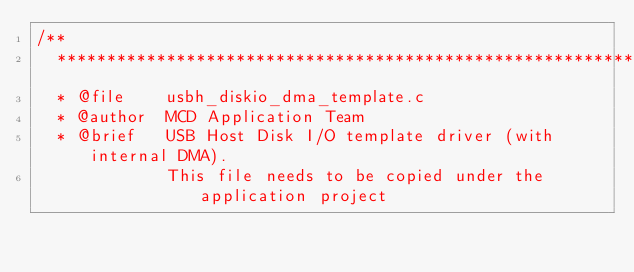Convert code to text. <code><loc_0><loc_0><loc_500><loc_500><_C_>/**
  ******************************************************************************
  * @file    usbh_diskio_dma_template.c
  * @author  MCD Application Team
  * @brief   USB Host Disk I/O template driver (with internal DMA).
             This file needs to be copied under the application project</code> 